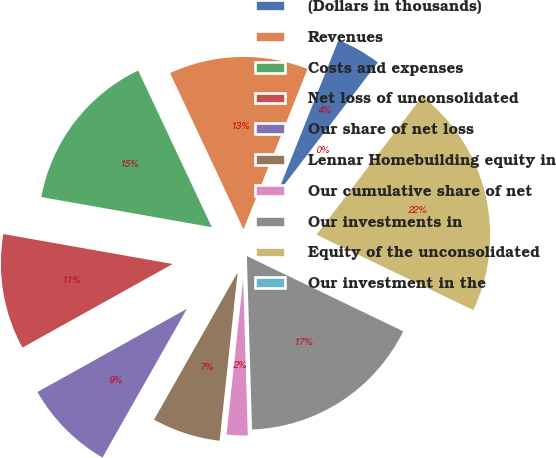<chart> <loc_0><loc_0><loc_500><loc_500><pie_chart><fcel>(Dollars in thousands)<fcel>Revenues<fcel>Costs and expenses<fcel>Net loss of unconsolidated<fcel>Our share of net loss<fcel>Lennar Homebuilding equity in<fcel>Our cumulative share of net<fcel>Our investments in<fcel>Equity of the unconsolidated<fcel>Our investment in the<nl><fcel>4.35%<fcel>13.04%<fcel>15.22%<fcel>10.87%<fcel>8.7%<fcel>6.52%<fcel>2.17%<fcel>17.39%<fcel>21.74%<fcel>0.0%<nl></chart> 